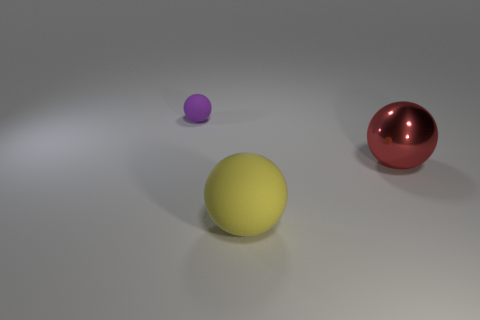Add 1 balls. How many objects exist? 4 Subtract all cyan rubber balls. Subtract all red balls. How many objects are left? 2 Add 1 purple rubber spheres. How many purple rubber spheres are left? 2 Add 1 green matte cubes. How many green matte cubes exist? 1 Subtract 1 purple spheres. How many objects are left? 2 